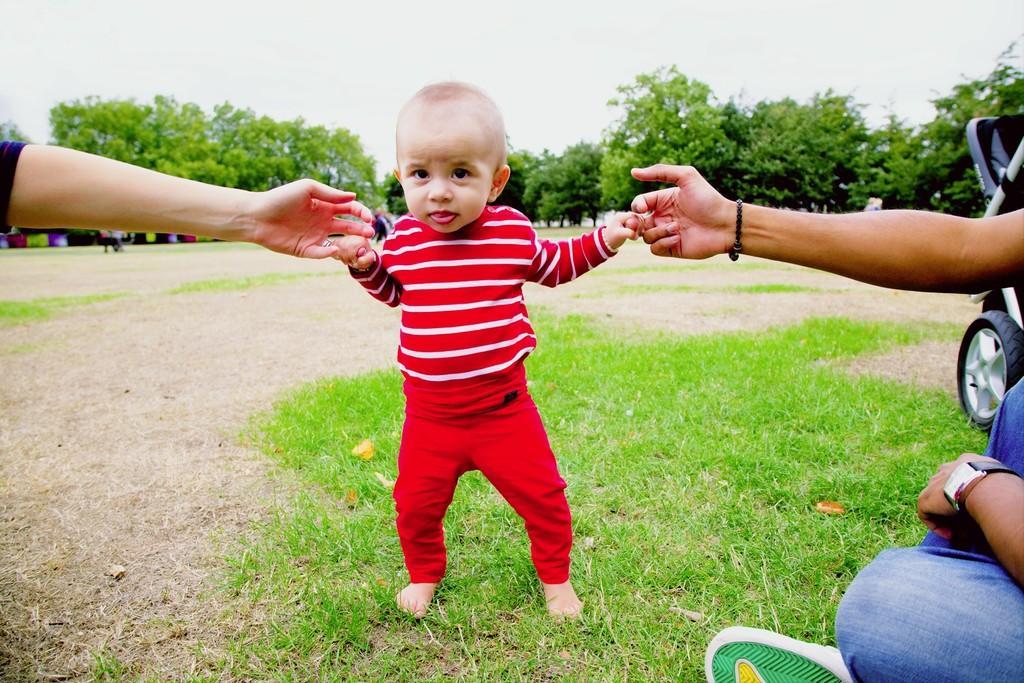Please provide a concise description of this image. In this image I can see three persons on grass and vehicles. In the background I can see trees and the sky. This image is taken may be in a park during a day. 